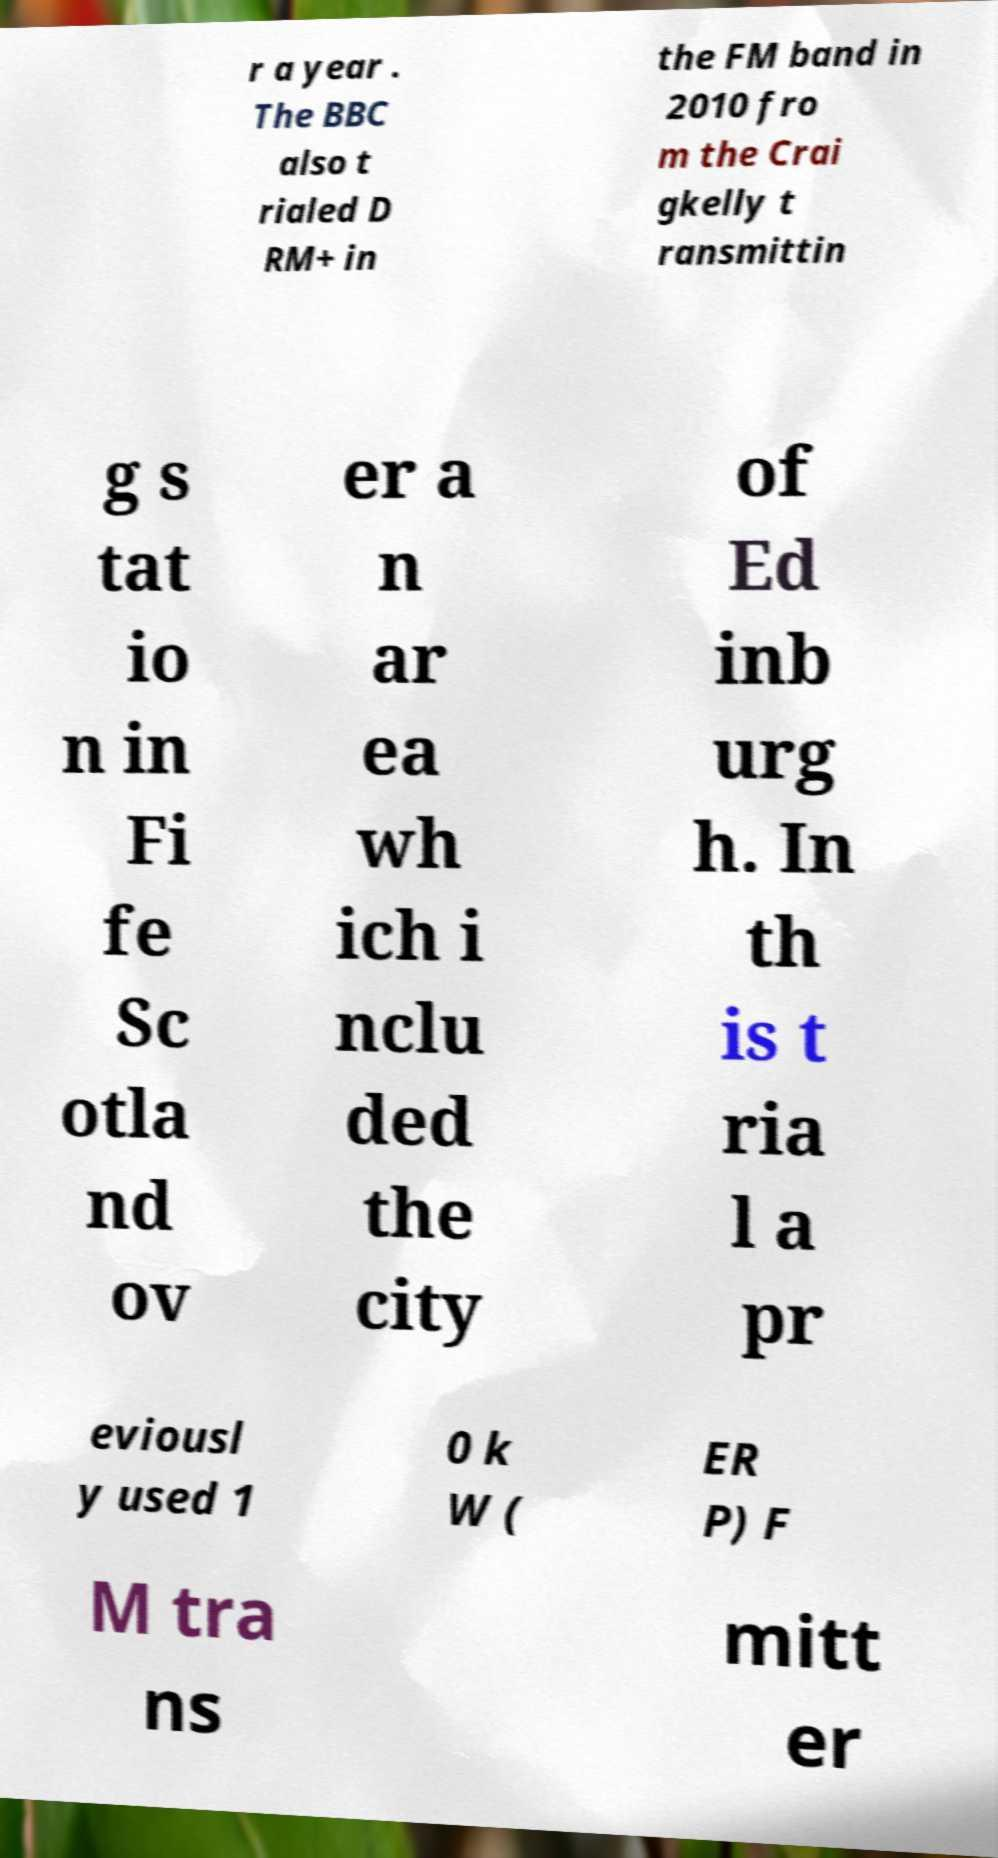Please identify and transcribe the text found in this image. r a year . The BBC also t rialed D RM+ in the FM band in 2010 fro m the Crai gkelly t ransmittin g s tat io n in Fi fe Sc otla nd ov er a n ar ea wh ich i nclu ded the city of Ed inb urg h. In th is t ria l a pr eviousl y used 1 0 k W ( ER P) F M tra ns mitt er 